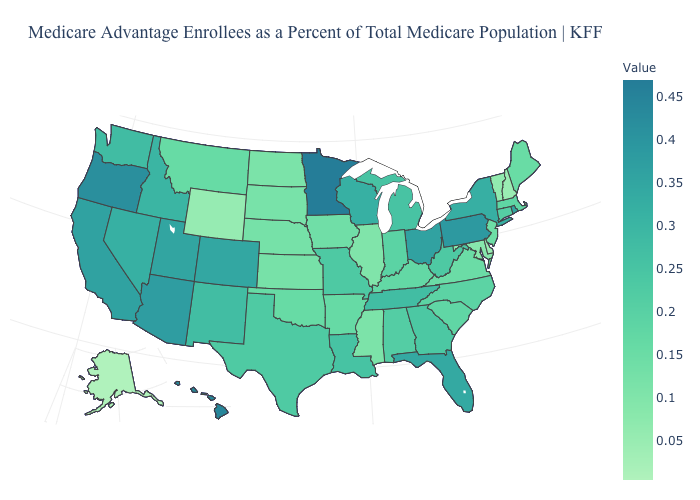Is the legend a continuous bar?
Give a very brief answer. Yes. Which states have the lowest value in the MidWest?
Keep it brief. Illinois. Which states have the lowest value in the USA?
Short answer required. Alaska. Among the states that border Nevada , which have the lowest value?
Keep it brief. Idaho. Does Washington have the lowest value in the USA?
Answer briefly. No. Which states have the highest value in the USA?
Short answer required. Minnesota. 